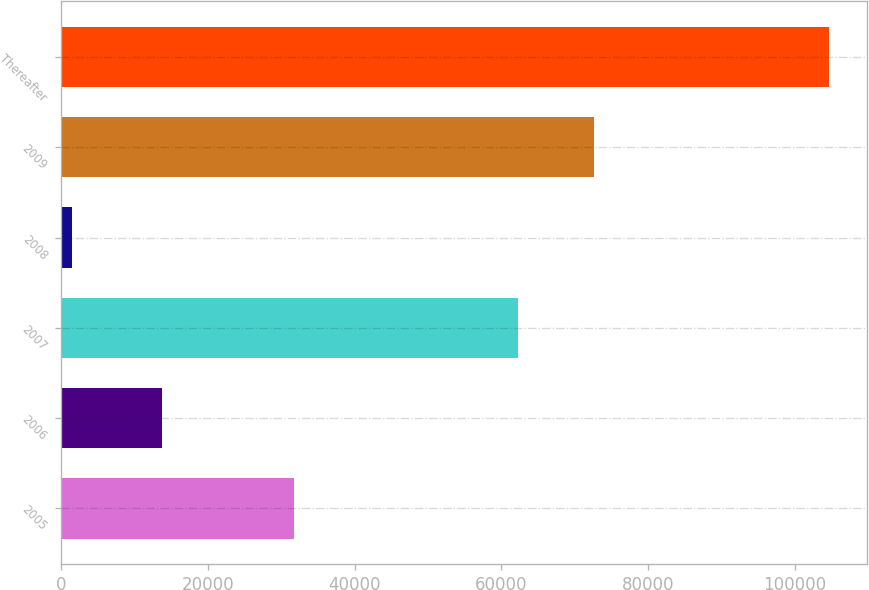Convert chart. <chart><loc_0><loc_0><loc_500><loc_500><bar_chart><fcel>2005<fcel>2006<fcel>2007<fcel>2008<fcel>2009<fcel>Thereafter<nl><fcel>31713<fcel>13740<fcel>62254<fcel>1507<fcel>72562.8<fcel>104595<nl></chart> 